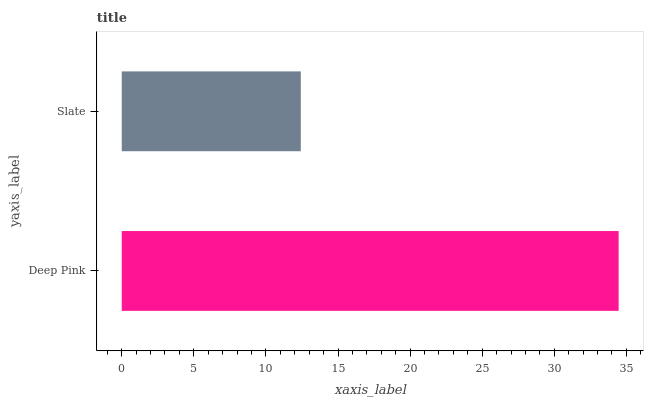Is Slate the minimum?
Answer yes or no. Yes. Is Deep Pink the maximum?
Answer yes or no. Yes. Is Slate the maximum?
Answer yes or no. No. Is Deep Pink greater than Slate?
Answer yes or no. Yes. Is Slate less than Deep Pink?
Answer yes or no. Yes. Is Slate greater than Deep Pink?
Answer yes or no. No. Is Deep Pink less than Slate?
Answer yes or no. No. Is Deep Pink the high median?
Answer yes or no. Yes. Is Slate the low median?
Answer yes or no. Yes. Is Slate the high median?
Answer yes or no. No. Is Deep Pink the low median?
Answer yes or no. No. 